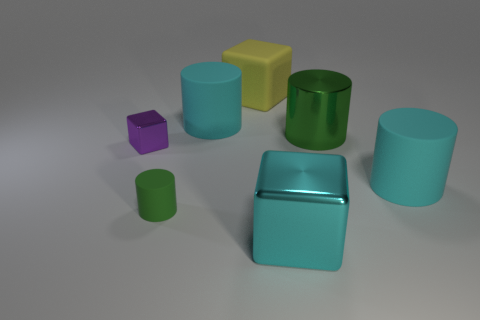What is the material of the small object behind the green cylinder that is in front of the green cylinder that is right of the matte cube?
Your answer should be very brief. Metal. How big is the rubber cylinder that is both to the left of the cyan cube and behind the small rubber object?
Keep it short and to the point. Large. Do the tiny purple metallic thing and the yellow thing have the same shape?
Your answer should be very brief. Yes. There is a green thing that is made of the same material as the yellow cube; what is its shape?
Keep it short and to the point. Cylinder. How many tiny objects are either gray spheres or purple blocks?
Give a very brief answer. 1. There is a cyan cylinder that is on the right side of the large green object; are there any cubes behind it?
Keep it short and to the point. Yes. Are there any large cyan metal objects?
Offer a terse response. Yes. What is the color of the small thing that is in front of the rubber cylinder on the right side of the yellow object?
Keep it short and to the point. Green. There is a cyan thing that is the same shape as the yellow thing; what is it made of?
Offer a very short reply. Metal. What number of matte objects have the same size as the matte block?
Offer a terse response. 2. 